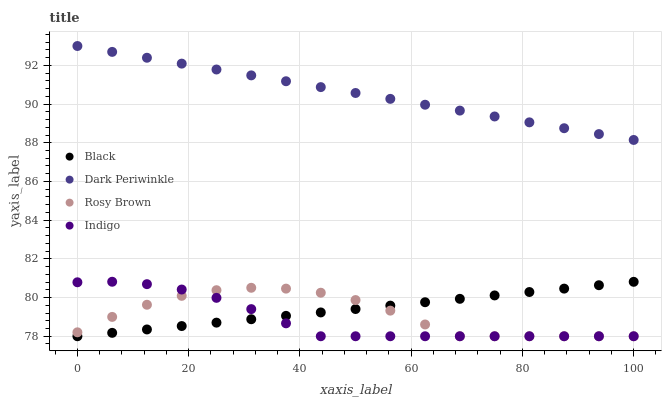Does Indigo have the minimum area under the curve?
Answer yes or no. Yes. Does Dark Periwinkle have the maximum area under the curve?
Answer yes or no. Yes. Does Rosy Brown have the minimum area under the curve?
Answer yes or no. No. Does Rosy Brown have the maximum area under the curve?
Answer yes or no. No. Is Dark Periwinkle the smoothest?
Answer yes or no. Yes. Is Rosy Brown the roughest?
Answer yes or no. Yes. Is Black the smoothest?
Answer yes or no. No. Is Black the roughest?
Answer yes or no. No. Does Indigo have the lowest value?
Answer yes or no. Yes. Does Dark Periwinkle have the lowest value?
Answer yes or no. No. Does Dark Periwinkle have the highest value?
Answer yes or no. Yes. Does Black have the highest value?
Answer yes or no. No. Is Indigo less than Dark Periwinkle?
Answer yes or no. Yes. Is Dark Periwinkle greater than Indigo?
Answer yes or no. Yes. Does Black intersect Indigo?
Answer yes or no. Yes. Is Black less than Indigo?
Answer yes or no. No. Is Black greater than Indigo?
Answer yes or no. No. Does Indigo intersect Dark Periwinkle?
Answer yes or no. No. 